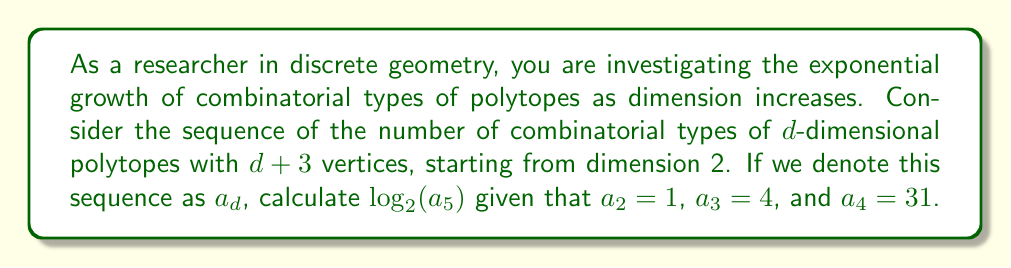Can you answer this question? To solve this problem, we need to follow these steps:

1) First, let's recall the sequence of combinatorial types of $d$-dimensional polytopes with $d+3$ vertices:

   For $d = 2$: $a_2 = 1$
   For $d = 3$: $a_3 = 4$
   For $d = 4$: $a_4 = 31$

2) This sequence grows exponentially. To find $a_5$, we need to recognize the pattern.

3) Let's calculate the ratios between consecutive terms:

   $\frac{a_3}{a_2} = \frac{4}{1} = 4$
   $\frac{a_4}{a_3} = \frac{31}{4} = 7.75$

4) We can see that the ratio is increasing. A good approximation for the next ratio would be:

   $\frac{a_5}{a_4} \approx 7.75 + (7.75 - 4) = 11.5$

5) Using this approximation:

   $a_5 \approx 31 * 11.5 = 356.5$

6) Rounding to the nearest integer:

   $a_5 \approx 357$

7) Now, we need to calculate $\log_2(a_5)$:

   $\log_2(357) \approx 8.48$

8) Rounding to two decimal places:

   $\log_2(357) \approx 8.48$
Answer: $\log_2(a_5) \approx 8.48$ 